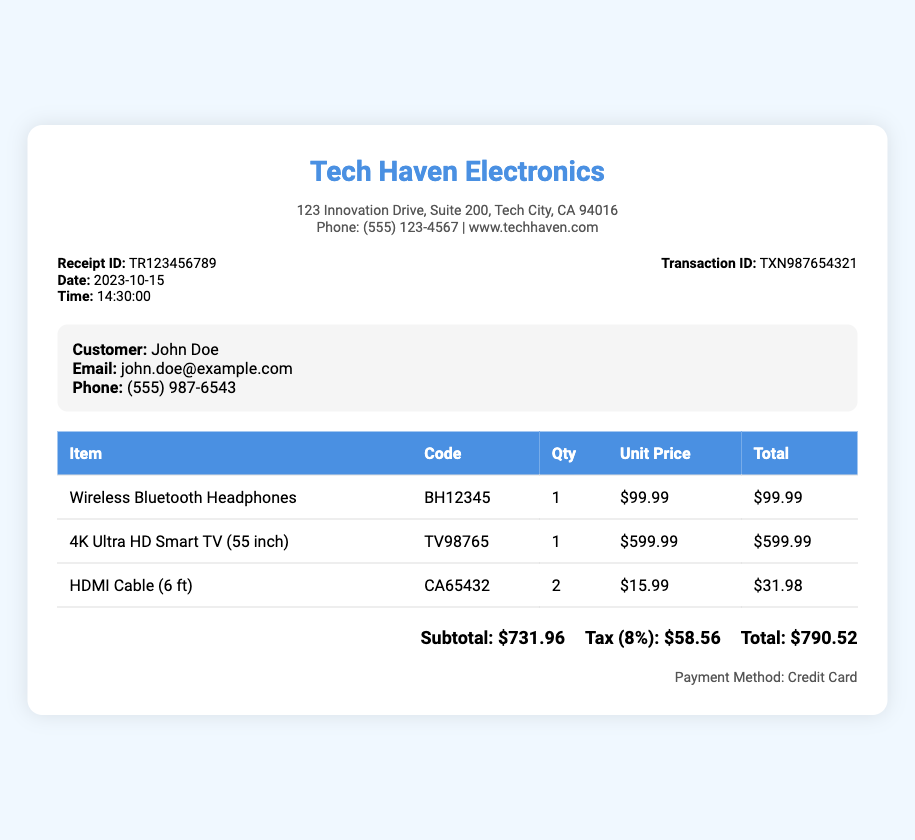What is the store name? The store name listed at the top of the receipt is "Tech Haven Electronics."
Answer: Tech Haven Electronics What is the receipt ID? The receipt ID is a unique identifier for the transaction, which is provided in the document as "TR123456789."
Answer: TR123456789 What is the date of the transaction? The date of the transaction can be found in the receipt details, which is "2023-10-15."
Answer: 2023-10-15 How many HDMI Cables were purchased? The quantity of HDMI Cables purchased is indicated in the table, which shows "2" units.
Answer: 2 What is the total tax amount? The tax amount is calculated based on the subtotal and is listed as "Tax (8%): $58.56."
Answer: $58.56 What is the unit price of the 4K Ultra HD Smart TV? The unit price of the 4K Ultra HD Smart TV is specified in the table as "$599.99."
Answer: $599.99 What payment method was used? The payment method mentioned at the end of the receipt is "Credit Card."
Answer: Credit Card What is the subtotal amount? The subtotal amount is clearly detailed in the total section as "$731.96."
Answer: $731.96 What is the total amount due? The total amount due is calculated and displayed as "$790.52" at the end of the receipt.
Answer: $790.52 